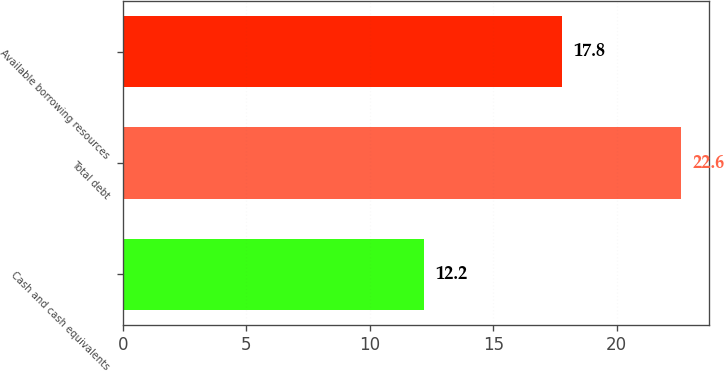Convert chart to OTSL. <chart><loc_0><loc_0><loc_500><loc_500><bar_chart><fcel>Cash and cash equivalents<fcel>Total debt<fcel>Available borrowing resources<nl><fcel>12.2<fcel>22.6<fcel>17.8<nl></chart> 